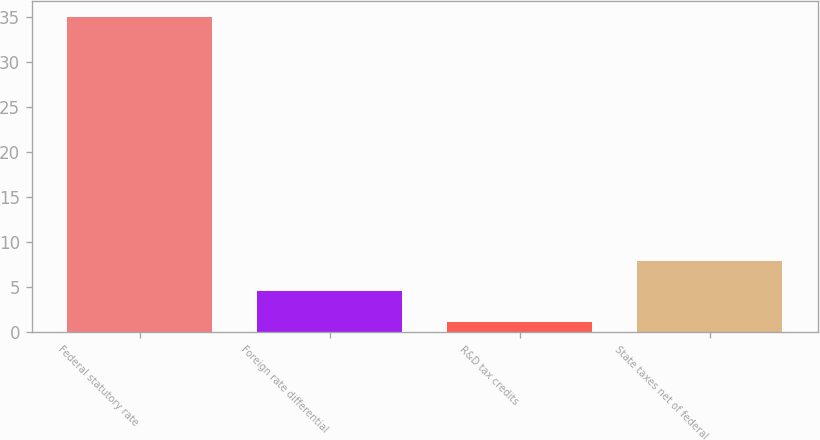Convert chart to OTSL. <chart><loc_0><loc_0><loc_500><loc_500><bar_chart><fcel>Federal statutory rate<fcel>Foreign rate differential<fcel>R&D tax credits<fcel>State taxes net of federal<nl><fcel>35<fcel>4.58<fcel>1.2<fcel>7.96<nl></chart> 